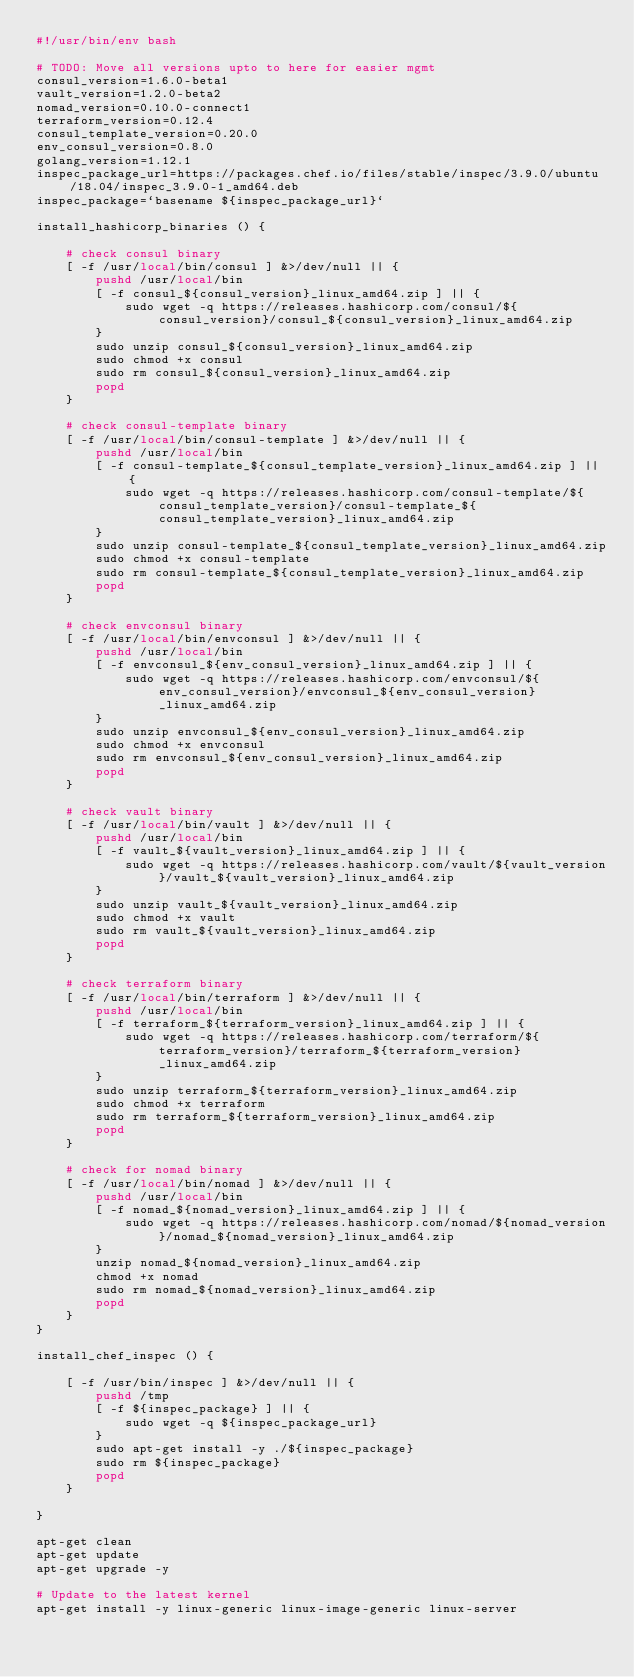<code> <loc_0><loc_0><loc_500><loc_500><_Bash_>#!/usr/bin/env bash

# TODO: Move all versions upto to here for easier mgmt
consul_version=1.6.0-beta1
vault_version=1.2.0-beta2
nomad_version=0.10.0-connect1
terraform_version=0.12.4
consul_template_version=0.20.0
env_consul_version=0.8.0
golang_version=1.12.1
inspec_package_url=https://packages.chef.io/files/stable/inspec/3.9.0/ubuntu/18.04/inspec_3.9.0-1_amd64.deb
inspec_package=`basename ${inspec_package_url}`

install_hashicorp_binaries () {

    # check consul binary
    [ -f /usr/local/bin/consul ] &>/dev/null || {
        pushd /usr/local/bin
        [ -f consul_${consul_version}_linux_amd64.zip ] || {
            sudo wget -q https://releases.hashicorp.com/consul/${consul_version}/consul_${consul_version}_linux_amd64.zip
        }
        sudo unzip consul_${consul_version}_linux_amd64.zip
        sudo chmod +x consul
        sudo rm consul_${consul_version}_linux_amd64.zip
        popd
    }

    # check consul-template binary
    [ -f /usr/local/bin/consul-template ] &>/dev/null || {
        pushd /usr/local/bin
        [ -f consul-template_${consul_template_version}_linux_amd64.zip ] || {
            sudo wget -q https://releases.hashicorp.com/consul-template/${consul_template_version}/consul-template_${consul_template_version}_linux_amd64.zip
        }
        sudo unzip consul-template_${consul_template_version}_linux_amd64.zip
        sudo chmod +x consul-template
        sudo rm consul-template_${consul_template_version}_linux_amd64.zip
        popd
    }

    # check envconsul binary
    [ -f /usr/local/bin/envconsul ] &>/dev/null || {
        pushd /usr/local/bin
        [ -f envconsul_${env_consul_version}_linux_amd64.zip ] || {
            sudo wget -q https://releases.hashicorp.com/envconsul/${env_consul_version}/envconsul_${env_consul_version}_linux_amd64.zip
        }
        sudo unzip envconsul_${env_consul_version}_linux_amd64.zip
        sudo chmod +x envconsul
        sudo rm envconsul_${env_consul_version}_linux_amd64.zip
        popd
    }

    # check vault binary
    [ -f /usr/local/bin/vault ] &>/dev/null || {
        pushd /usr/local/bin
        [ -f vault_${vault_version}_linux_amd64.zip ] || {
            sudo wget -q https://releases.hashicorp.com/vault/${vault_version}/vault_${vault_version}_linux_amd64.zip
        }
        sudo unzip vault_${vault_version}_linux_amd64.zip
        sudo chmod +x vault
        sudo rm vault_${vault_version}_linux_amd64.zip
        popd
    }

    # check terraform binary
    [ -f /usr/local/bin/terraform ] &>/dev/null || {
        pushd /usr/local/bin
        [ -f terraform_${terraform_version}_linux_amd64.zip ] || {
            sudo wget -q https://releases.hashicorp.com/terraform/${terraform_version}/terraform_${terraform_version}_linux_amd64.zip
        }
        sudo unzip terraform_${terraform_version}_linux_amd64.zip
        sudo chmod +x terraform
        sudo rm terraform_${terraform_version}_linux_amd64.zip
        popd
    }

    # check for nomad binary
    [ -f /usr/local/bin/nomad ] &>/dev/null || {
        pushd /usr/local/bin
        [ -f nomad_${nomad_version}_linux_amd64.zip ] || {
            sudo wget -q https://releases.hashicorp.com/nomad/${nomad_version}/nomad_${nomad_version}_linux_amd64.zip
        }
        unzip nomad_${nomad_version}_linux_amd64.zip
        chmod +x nomad
        sudo rm nomad_${nomad_version}_linux_amd64.zip
        popd
    }
}

install_chef_inspec () {
    
    [ -f /usr/bin/inspec ] &>/dev/null || {
        pushd /tmp
        [ -f ${inspec_package} ] || {
            sudo wget -q ${inspec_package_url}
        }
        sudo apt-get install -y ./${inspec_package}
        sudo rm ${inspec_package}
        popd
    }    

}

apt-get clean
apt-get update
apt-get upgrade -y

# Update to the latest kernel
apt-get install -y linux-generic linux-image-generic linux-server
</code> 